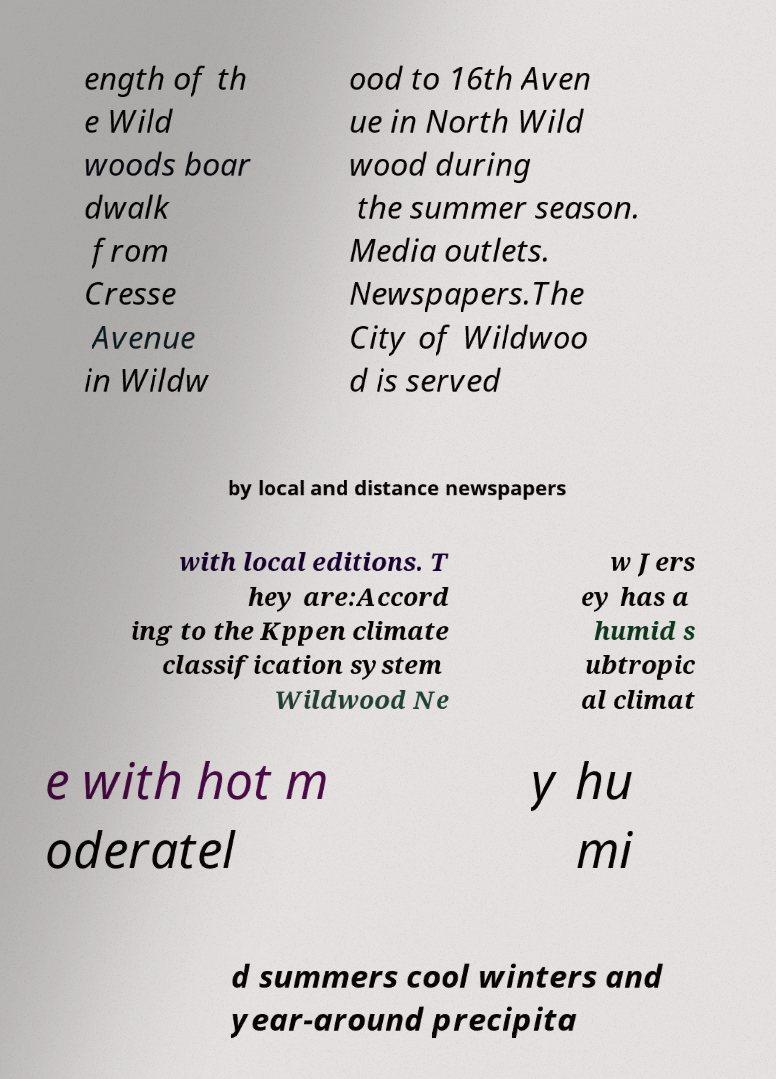Can you read and provide the text displayed in the image?This photo seems to have some interesting text. Can you extract and type it out for me? ength of th e Wild woods boar dwalk from Cresse Avenue in Wildw ood to 16th Aven ue in North Wild wood during the summer season. Media outlets. Newspapers.The City of Wildwoo d is served by local and distance newspapers with local editions. T hey are:Accord ing to the Kppen climate classification system Wildwood Ne w Jers ey has a humid s ubtropic al climat e with hot m oderatel y hu mi d summers cool winters and year-around precipita 